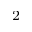Convert formula to latex. <formula><loc_0><loc_0><loc_500><loc_500>^ { 2 }</formula> 